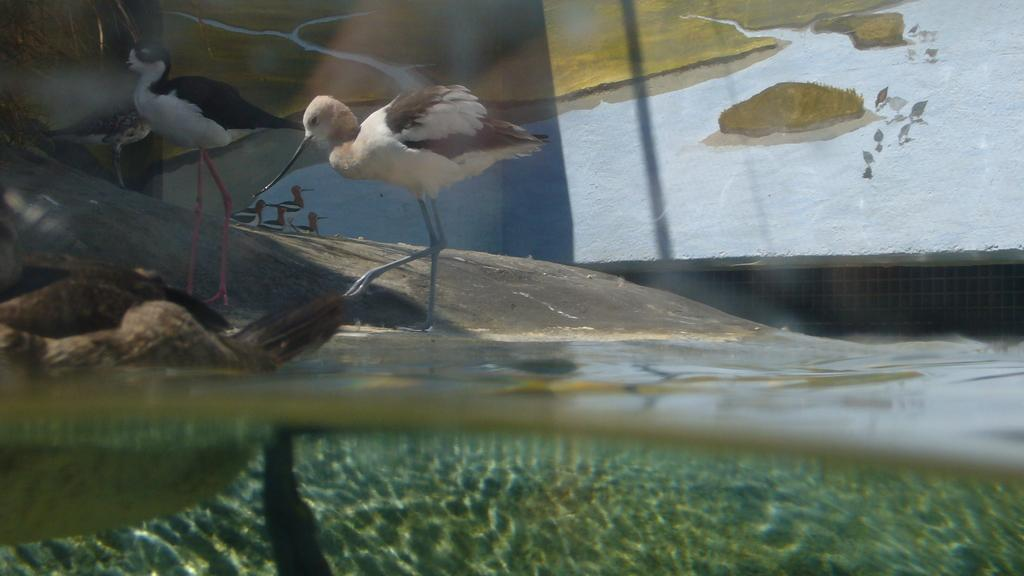What type of animals can be seen in the image? There are birds in the image. What is visible at the bottom of the image? There is water visible at the bottom of the image. What object can be seen in the image besides the birds and water? There is a rock in the image. What can be seen in the background of the image? There is a wall in the background of the image. What type of yard can be seen in the image? There is no yard present in the image; it features birds, water, a rock, and a wall. 